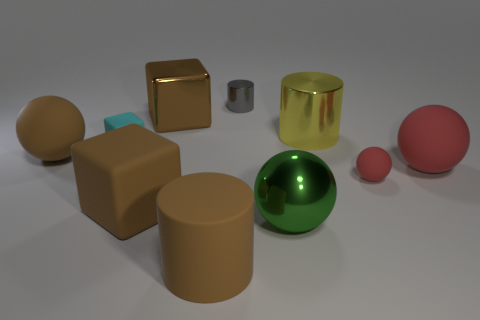What is the material of the small object that is in front of the ball that is on the left side of the shiny thing on the left side of the gray shiny object?
Ensure brevity in your answer.  Rubber. Is the color of the big rubber ball that is to the right of the large shiny cylinder the same as the tiny rubber object in front of the brown ball?
Your response must be concise. Yes. Are there more large brown spheres than matte cubes?
Make the answer very short. No. What number of large rubber cubes are the same color as the small metallic object?
Your answer should be compact. 0. What color is the big metallic thing that is the same shape as the small cyan object?
Give a very brief answer. Brown. There is a cylinder that is left of the big yellow cylinder and behind the small red rubber sphere; what is its material?
Provide a short and direct response. Metal. Do the sphere that is on the left side of the shiny sphere and the tiny thing that is in front of the big red matte sphere have the same material?
Provide a short and direct response. Yes. What is the size of the gray object?
Your response must be concise. Small. There is another metallic thing that is the same shape as the large yellow metallic thing; what is its size?
Make the answer very short. Small. There is a small red matte thing; how many gray things are behind it?
Offer a very short reply. 1. 